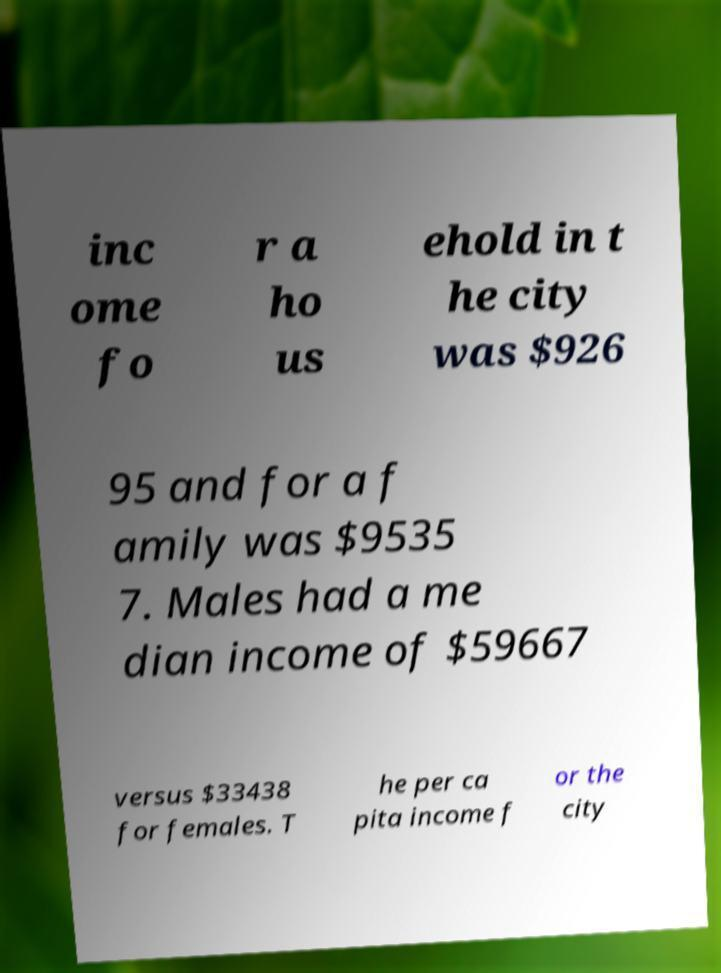Please read and relay the text visible in this image. What does it say? inc ome fo r a ho us ehold in t he city was $926 95 and for a f amily was $9535 7. Males had a me dian income of $59667 versus $33438 for females. T he per ca pita income f or the city 